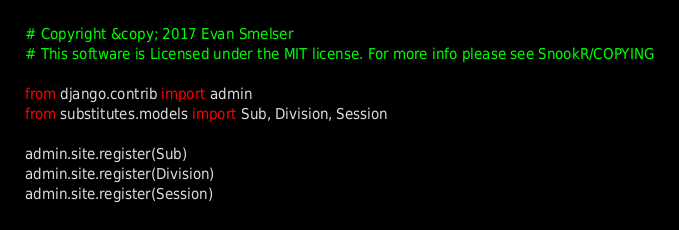<code> <loc_0><loc_0><loc_500><loc_500><_Python_># Copyright &copy; 2017 Evan Smelser
# This software is Licensed under the MIT license. For more info please see SnookR/COPYING

from django.contrib import admin
from substitutes.models import Sub, Division, Session

admin.site.register(Sub)
admin.site.register(Division)
admin.site.register(Session)</code> 